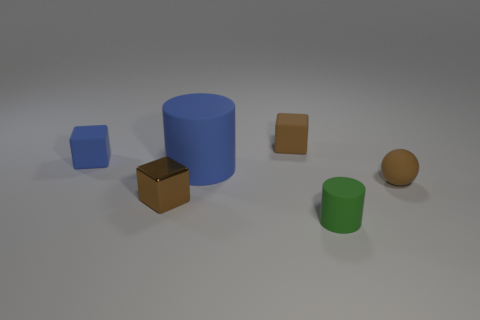Subtract all purple blocks. Subtract all gray cylinders. How many blocks are left? 3 Add 3 small yellow spheres. How many objects exist? 9 Subtract all spheres. How many objects are left? 5 Subtract all brown rubber spheres. Subtract all cubes. How many objects are left? 2 Add 6 green matte cylinders. How many green matte cylinders are left? 7 Add 4 tiny matte blocks. How many tiny matte blocks exist? 6 Subtract 0 yellow spheres. How many objects are left? 6 